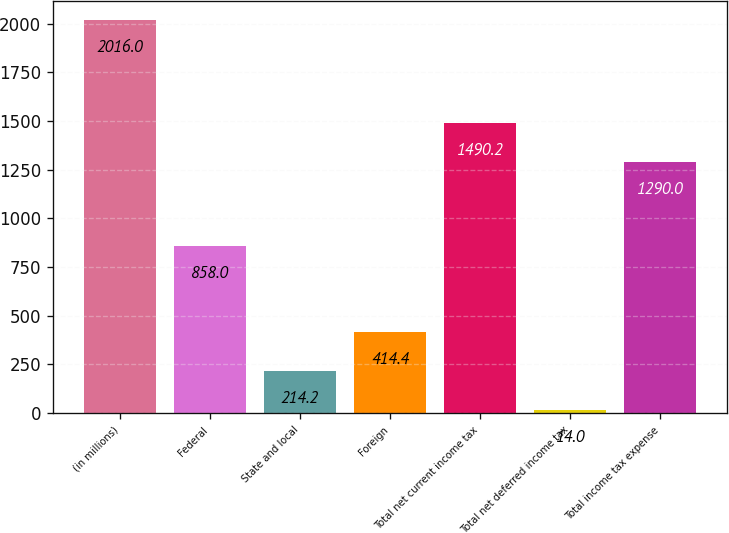<chart> <loc_0><loc_0><loc_500><loc_500><bar_chart><fcel>(in millions)<fcel>Federal<fcel>State and local<fcel>Foreign<fcel>Total net current income tax<fcel>Total net deferred income tax<fcel>Total income tax expense<nl><fcel>2016<fcel>858<fcel>214.2<fcel>414.4<fcel>1490.2<fcel>14<fcel>1290<nl></chart> 